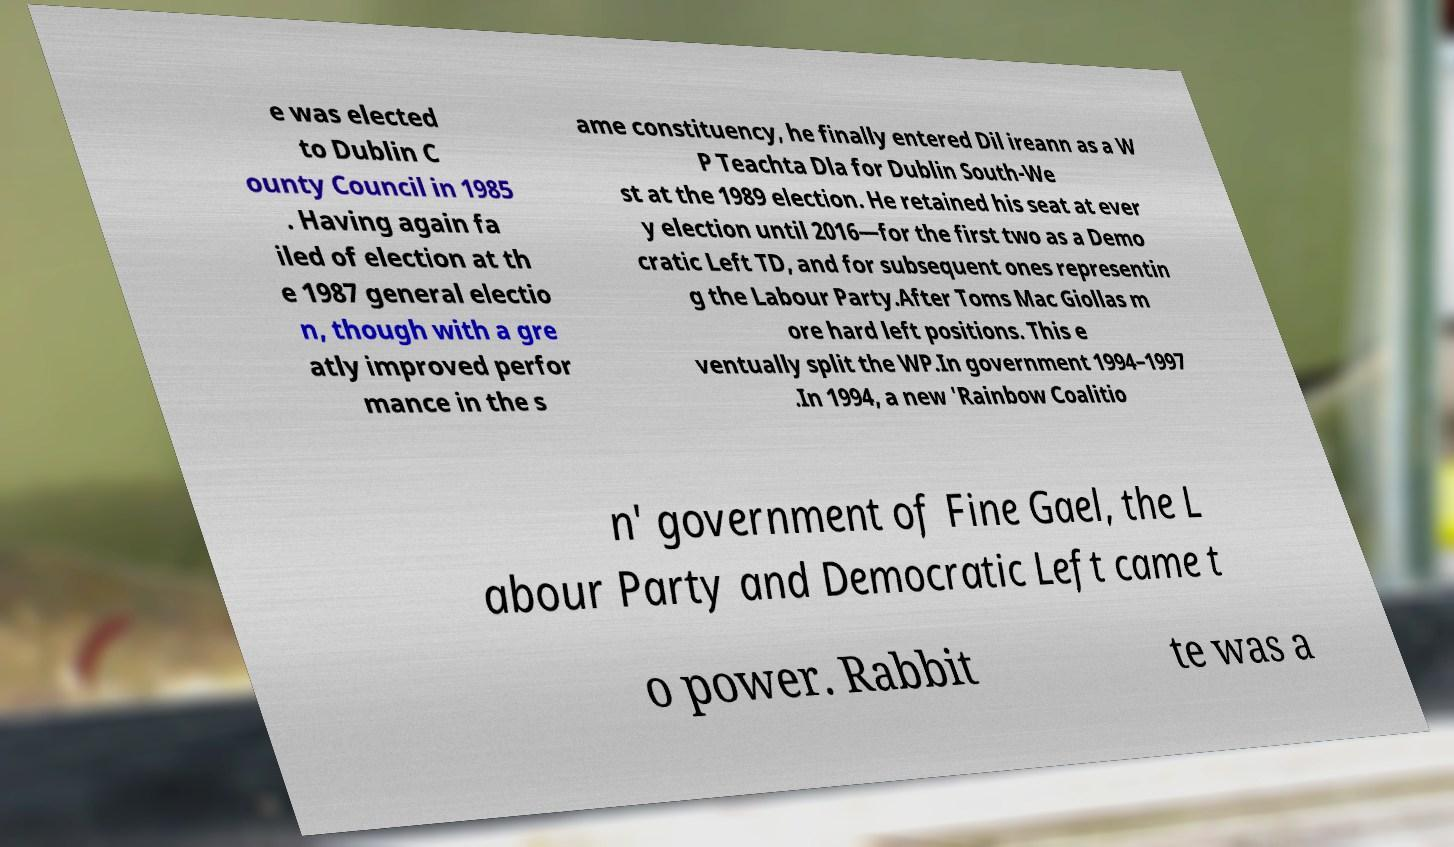For documentation purposes, I need the text within this image transcribed. Could you provide that? e was elected to Dublin C ounty Council in 1985 . Having again fa iled of election at th e 1987 general electio n, though with a gre atly improved perfor mance in the s ame constituency, he finally entered Dil ireann as a W P Teachta Dla for Dublin South-We st at the 1989 election. He retained his seat at ever y election until 2016—for the first two as a Demo cratic Left TD, and for subsequent ones representin g the Labour Party.After Toms Mac Giollas m ore hard left positions. This e ventually split the WP.In government 1994–1997 .In 1994, a new 'Rainbow Coalitio n' government of Fine Gael, the L abour Party and Democratic Left came t o power. Rabbit te was a 